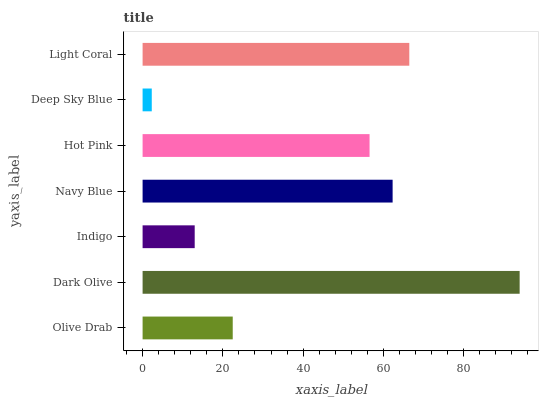Is Deep Sky Blue the minimum?
Answer yes or no. Yes. Is Dark Olive the maximum?
Answer yes or no. Yes. Is Indigo the minimum?
Answer yes or no. No. Is Indigo the maximum?
Answer yes or no. No. Is Dark Olive greater than Indigo?
Answer yes or no. Yes. Is Indigo less than Dark Olive?
Answer yes or no. Yes. Is Indigo greater than Dark Olive?
Answer yes or no. No. Is Dark Olive less than Indigo?
Answer yes or no. No. Is Hot Pink the high median?
Answer yes or no. Yes. Is Hot Pink the low median?
Answer yes or no. Yes. Is Indigo the high median?
Answer yes or no. No. Is Navy Blue the low median?
Answer yes or no. No. 